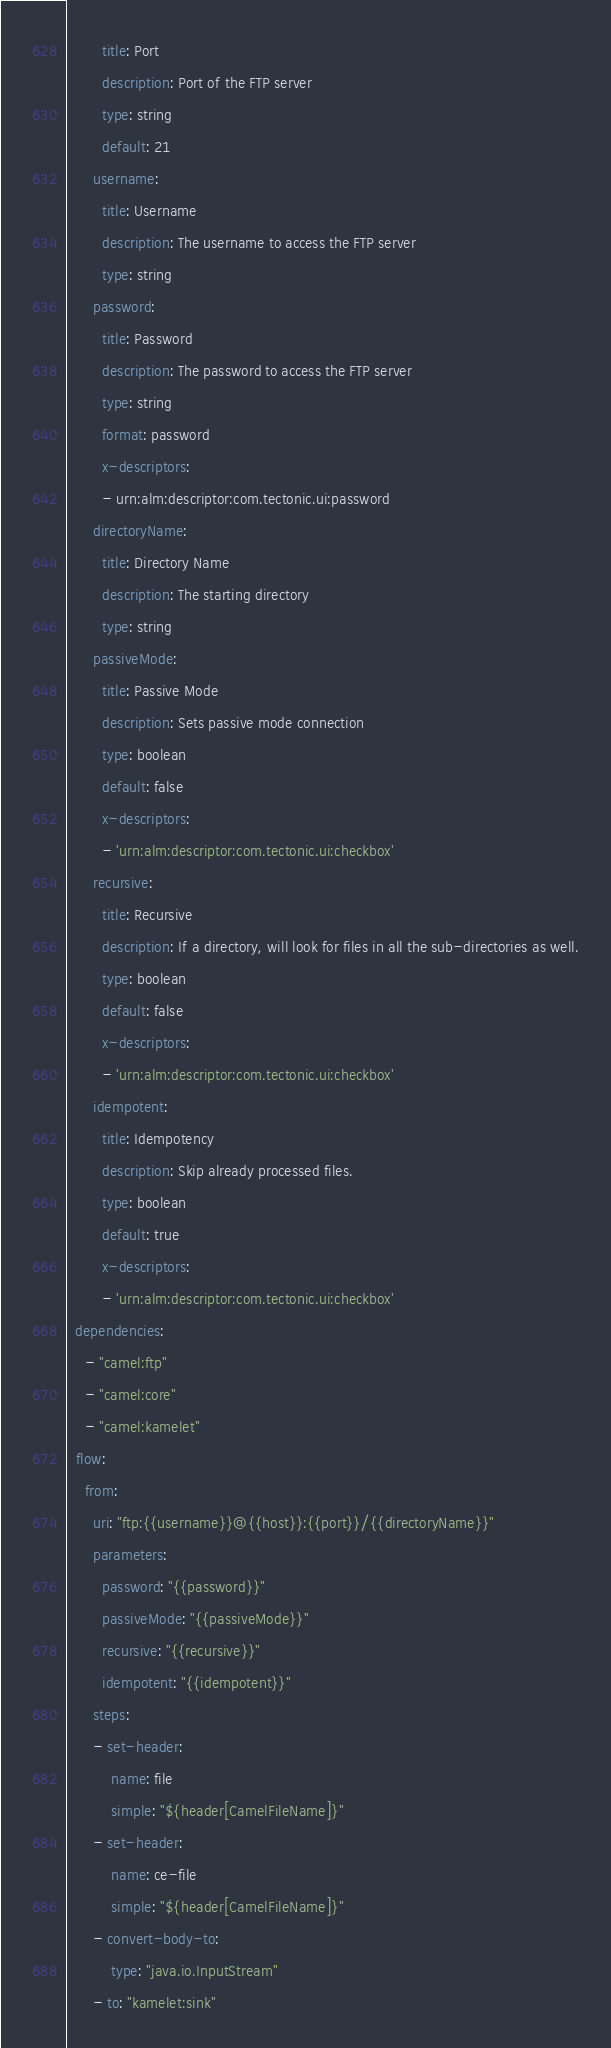<code> <loc_0><loc_0><loc_500><loc_500><_YAML_>        title: Port
        description: Port of the FTP server
        type: string
        default: 21
      username:
        title: Username
        description: The username to access the FTP server
        type: string
      password:
        title: Password
        description: The password to access the FTP server
        type: string
        format: password
        x-descriptors:
        - urn:alm:descriptor:com.tectonic.ui:password
      directoryName:
        title: Directory Name
        description: The starting directory
        type: string
      passiveMode:
        title: Passive Mode
        description: Sets passive mode connection
        type: boolean
        default: false
        x-descriptors:
        - 'urn:alm:descriptor:com.tectonic.ui:checkbox'
      recursive:
        title: Recursive
        description: If a directory, will look for files in all the sub-directories as well.
        type: boolean
        default: false
        x-descriptors:
        - 'urn:alm:descriptor:com.tectonic.ui:checkbox'
      idempotent:
        title: Idempotency
        description: Skip already processed files.
        type: boolean
        default: true
        x-descriptors:
        - 'urn:alm:descriptor:com.tectonic.ui:checkbox'
  dependencies:
    - "camel:ftp"
    - "camel:core"
    - "camel:kamelet"
  flow:
    from:
      uri: "ftp:{{username}}@{{host}}:{{port}}/{{directoryName}}"
      parameters:
        password: "{{password}}"
        passiveMode: "{{passiveMode}}"
        recursive: "{{recursive}}"
        idempotent: "{{idempotent}}"
      steps:
      - set-header:
          name: file
          simple: "${header[CamelFileName]}"
      - set-header:
          name: ce-file
          simple: "${header[CamelFileName]}"
      - convert-body-to:
          type: "java.io.InputStream"
      - to: "kamelet:sink"
</code> 